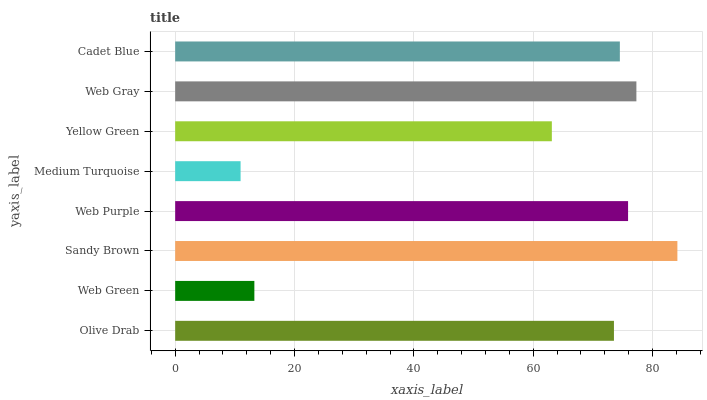Is Medium Turquoise the minimum?
Answer yes or no. Yes. Is Sandy Brown the maximum?
Answer yes or no. Yes. Is Web Green the minimum?
Answer yes or no. No. Is Web Green the maximum?
Answer yes or no. No. Is Olive Drab greater than Web Green?
Answer yes or no. Yes. Is Web Green less than Olive Drab?
Answer yes or no. Yes. Is Web Green greater than Olive Drab?
Answer yes or no. No. Is Olive Drab less than Web Green?
Answer yes or no. No. Is Cadet Blue the high median?
Answer yes or no. Yes. Is Olive Drab the low median?
Answer yes or no. Yes. Is Yellow Green the high median?
Answer yes or no. No. Is Yellow Green the low median?
Answer yes or no. No. 